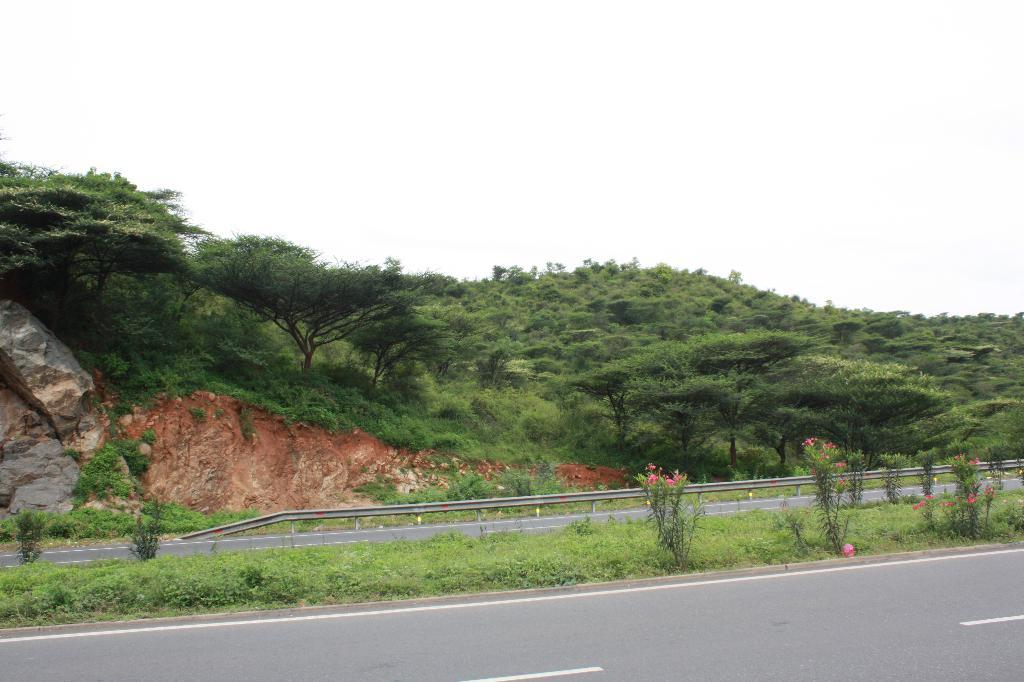What type of pathway can be seen in the image? There is a road in the image. What type of vegetation is present in the image? Grass, plants, and trees are visible in the image. What kind of elevation can be seen in the image? There is a hill in the image. What is visible in the background of the image? The sky is visible in the image. What type of feast is being prepared on the hill in the image? There is no feast or any indication of food preparation in the image; it features a road, grass, plants, trees, a hill, and the sky. What type of oatmeal is being served on the road in the image? There is no oatmeal or any food visible in the image; it features a road, grass, plants, trees, a hill, and the sky. 